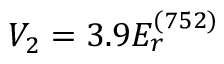Convert formula to latex. <formula><loc_0><loc_0><loc_500><loc_500>V _ { 2 } = 3 . 9 E _ { r } ^ { ( 7 5 2 ) }</formula> 